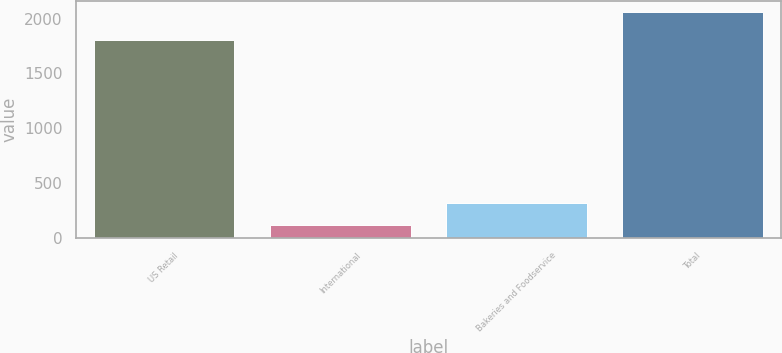Convert chart to OTSL. <chart><loc_0><loc_0><loc_500><loc_500><bar_chart><fcel>US Retail<fcel>International<fcel>Bakeries and Foodservice<fcel>Total<nl><fcel>1809<fcel>119<fcel>313.1<fcel>2060<nl></chart> 